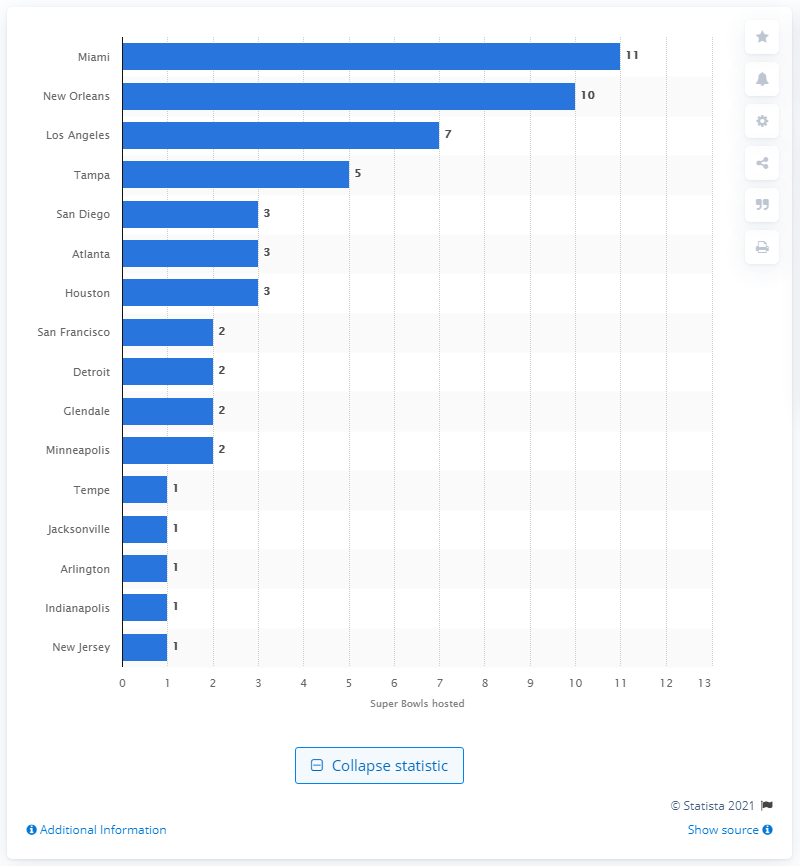Point out several critical features in this image. Miami has hosted the most Super Bowls in the history of the National Football League (NFL). 